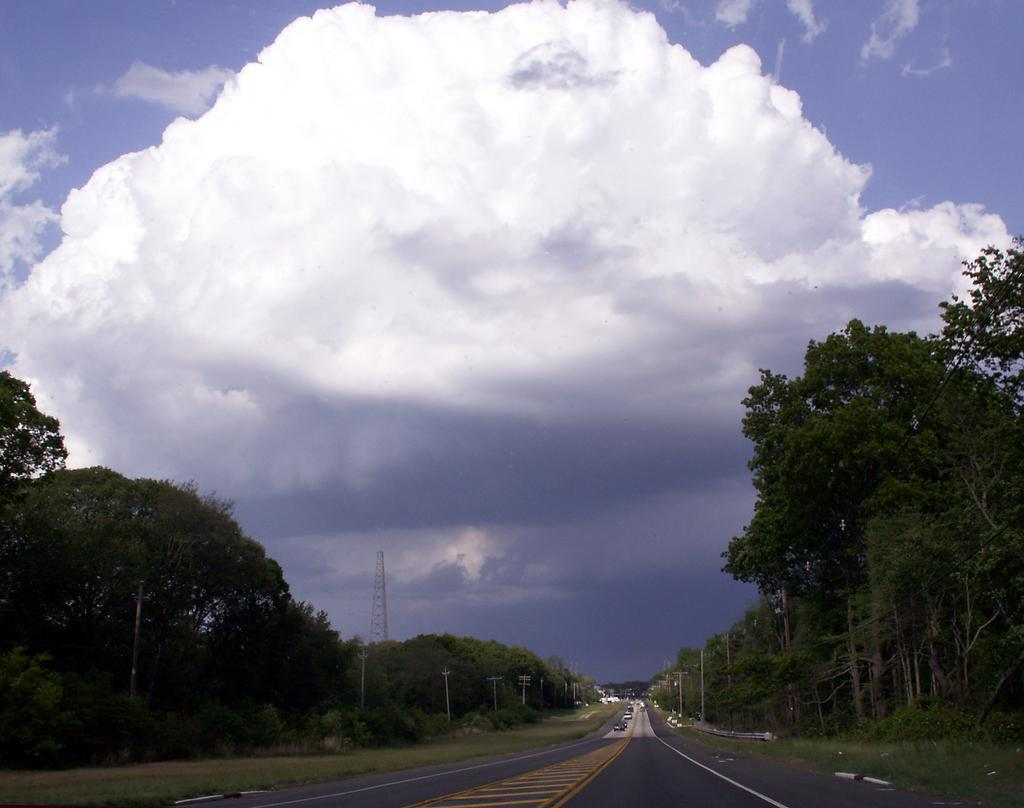What type of natural elements can be seen in the image? There are trees in the image. What man-made structures are visible in the image? There are current polls and vehicles on the road in the image. What part of the natural environment is visible in the image? The sky is visible in the image. What can be seen in the sky in the image? Clouds are present in the sky. Where is the kettle located in the image? There is no kettle present in the image. What type of school can be seen in the image? There is no school present in the image. 